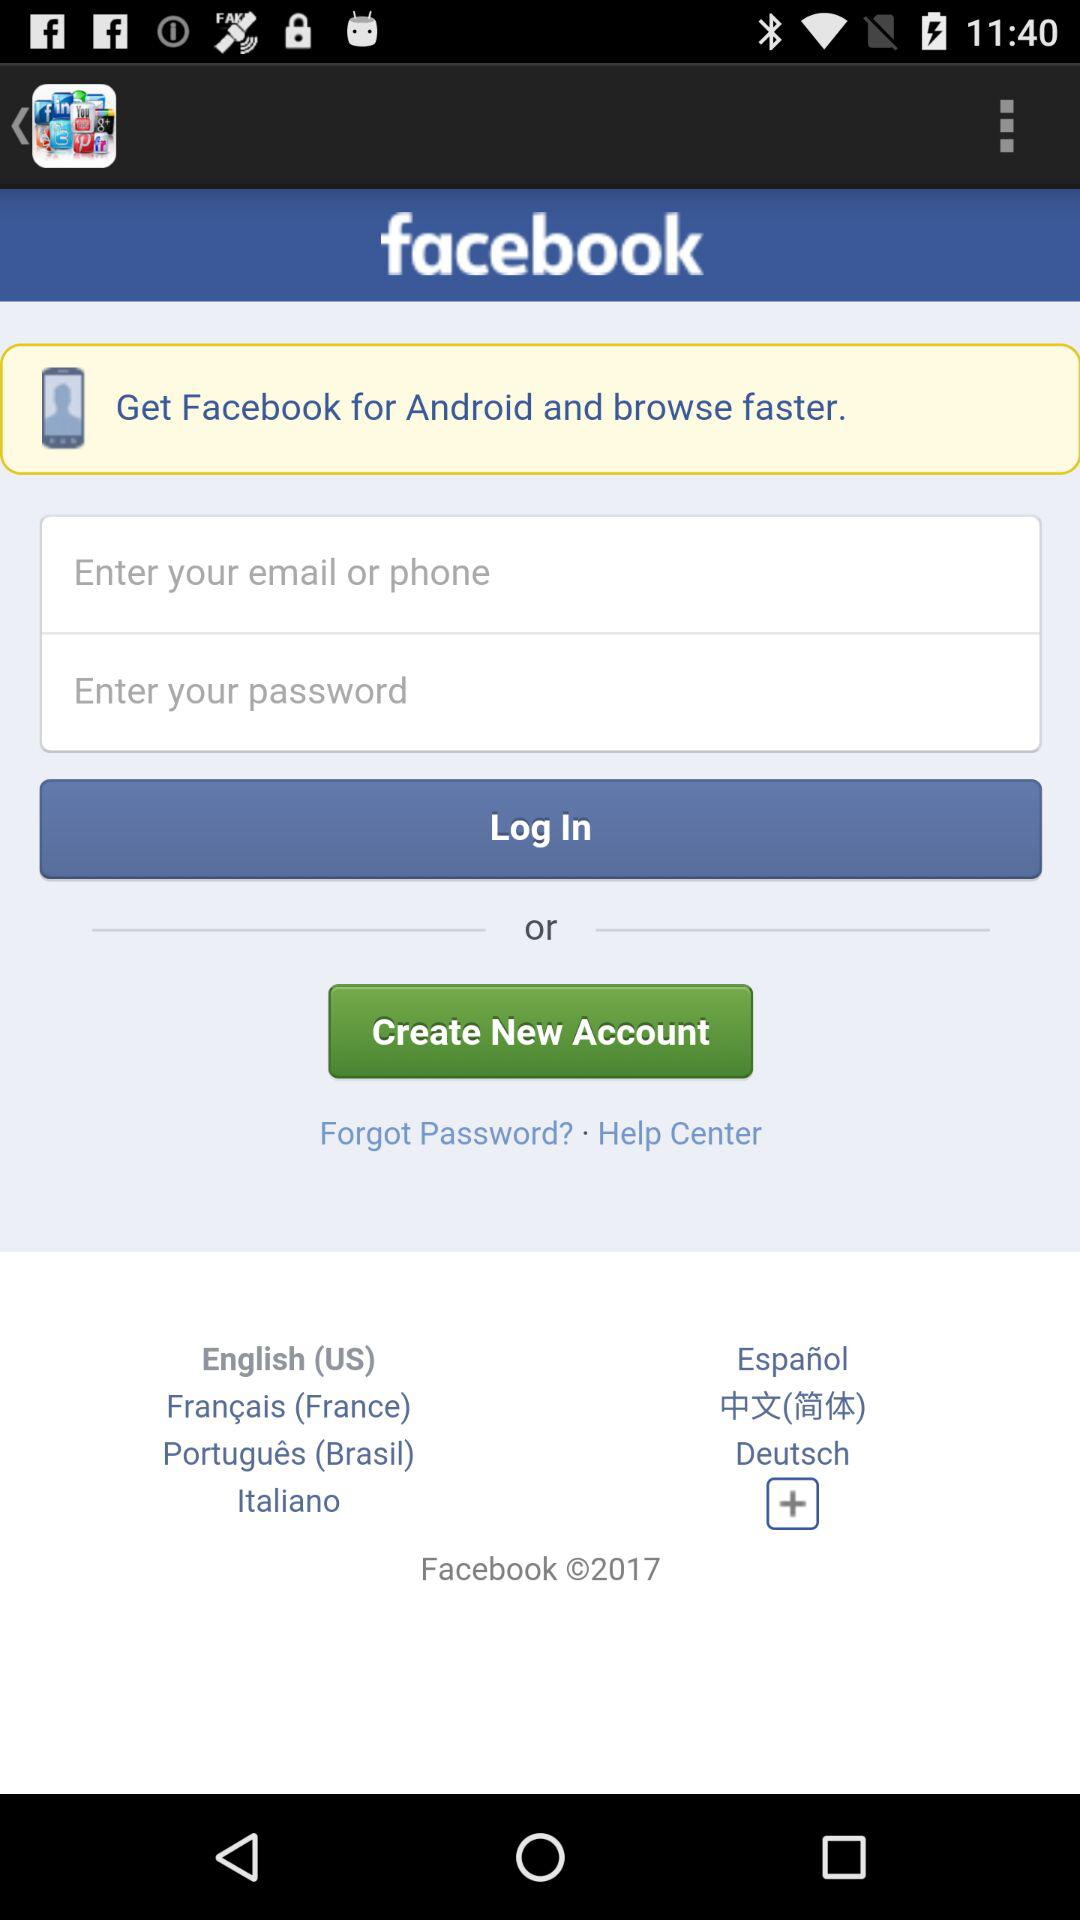How many languages are available in the language drop down?
Answer the question using a single word or phrase. 7 